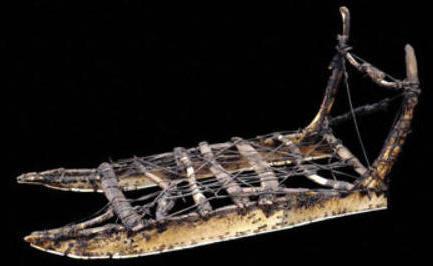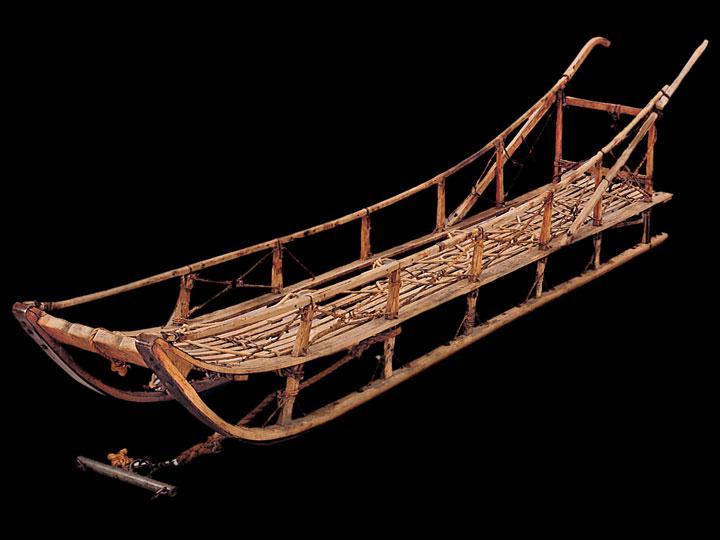The first image is the image on the left, the second image is the image on the right. For the images shown, is this caption "The sled in the left image is facing right." true? Answer yes or no. No. 